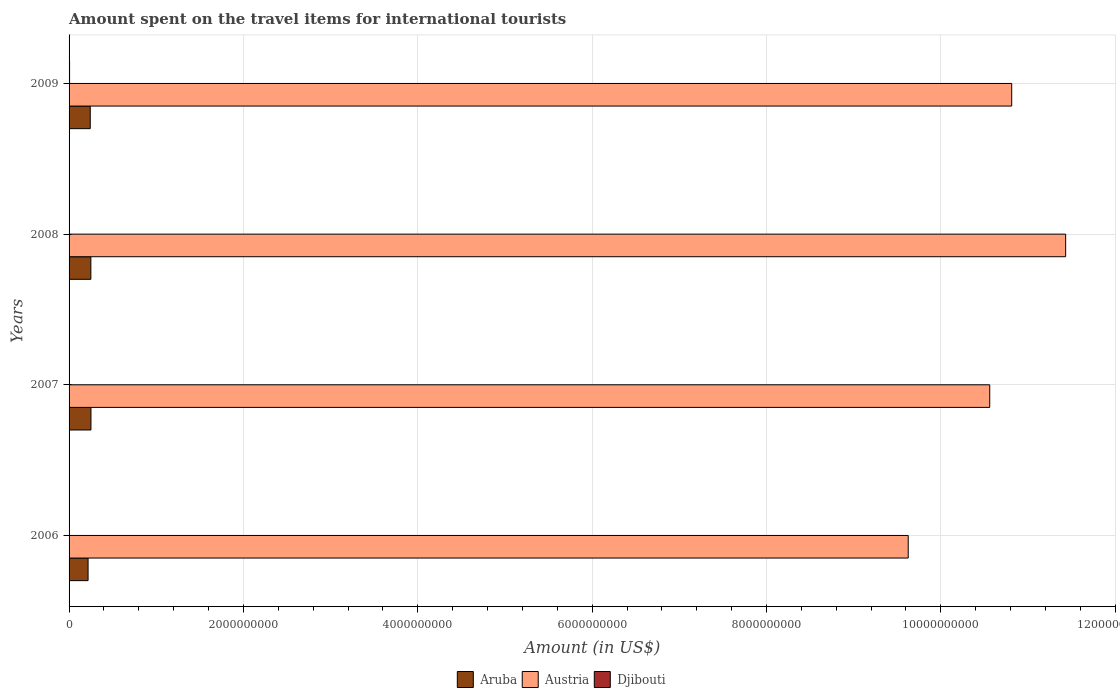How many different coloured bars are there?
Ensure brevity in your answer.  3. Are the number of bars on each tick of the Y-axis equal?
Offer a terse response. Yes. What is the label of the 3rd group of bars from the top?
Your response must be concise. 2007. In how many cases, is the number of bars for a given year not equal to the number of legend labels?
Provide a succinct answer. 0. What is the amount spent on the travel items for international tourists in Djibouti in 2008?
Provide a succinct answer. 3.70e+06. Across all years, what is the maximum amount spent on the travel items for international tourists in Aruba?
Your answer should be very brief. 2.51e+08. Across all years, what is the minimum amount spent on the travel items for international tourists in Djibouti?
Provide a succinct answer. 2.60e+06. What is the total amount spent on the travel items for international tourists in Aruba in the graph?
Your answer should be compact. 9.62e+08. What is the difference between the amount spent on the travel items for international tourists in Aruba in 2007 and that in 2008?
Ensure brevity in your answer.  1.00e+06. What is the difference between the amount spent on the travel items for international tourists in Djibouti in 2006 and the amount spent on the travel items for international tourists in Aruba in 2009?
Ensure brevity in your answer.  -2.40e+08. What is the average amount spent on the travel items for international tourists in Aruba per year?
Ensure brevity in your answer.  2.40e+08. In the year 2008, what is the difference between the amount spent on the travel items for international tourists in Djibouti and amount spent on the travel items for international tourists in Aruba?
Offer a very short reply. -2.46e+08. What is the ratio of the amount spent on the travel items for international tourists in Austria in 2006 to that in 2009?
Your answer should be compact. 0.89. Is the amount spent on the travel items for international tourists in Aruba in 2008 less than that in 2009?
Ensure brevity in your answer.  No. What is the difference between the highest and the second highest amount spent on the travel items for international tourists in Austria?
Ensure brevity in your answer.  6.19e+08. What is the difference between the highest and the lowest amount spent on the travel items for international tourists in Austria?
Make the answer very short. 1.81e+09. Is the sum of the amount spent on the travel items for international tourists in Austria in 2007 and 2008 greater than the maximum amount spent on the travel items for international tourists in Aruba across all years?
Offer a very short reply. Yes. What does the 1st bar from the top in 2009 represents?
Give a very brief answer. Djibouti. What does the 2nd bar from the bottom in 2009 represents?
Ensure brevity in your answer.  Austria. Is it the case that in every year, the sum of the amount spent on the travel items for international tourists in Austria and amount spent on the travel items for international tourists in Djibouti is greater than the amount spent on the travel items for international tourists in Aruba?
Your response must be concise. Yes. How many bars are there?
Provide a short and direct response. 12. Are all the bars in the graph horizontal?
Offer a terse response. Yes. How many years are there in the graph?
Your answer should be very brief. 4. How many legend labels are there?
Make the answer very short. 3. How are the legend labels stacked?
Offer a very short reply. Horizontal. What is the title of the graph?
Your answer should be very brief. Amount spent on the travel items for international tourists. Does "Uzbekistan" appear as one of the legend labels in the graph?
Offer a terse response. No. What is the label or title of the X-axis?
Give a very brief answer. Amount (in US$). What is the Amount (in US$) of Aruba in 2006?
Offer a very short reply. 2.18e+08. What is the Amount (in US$) in Austria in 2006?
Offer a very short reply. 9.63e+09. What is the Amount (in US$) of Djibouti in 2006?
Give a very brief answer. 3.50e+06. What is the Amount (in US$) of Aruba in 2007?
Ensure brevity in your answer.  2.51e+08. What is the Amount (in US$) in Austria in 2007?
Give a very brief answer. 1.06e+1. What is the Amount (in US$) of Djibouti in 2007?
Your response must be concise. 2.60e+06. What is the Amount (in US$) of Aruba in 2008?
Your answer should be compact. 2.50e+08. What is the Amount (in US$) of Austria in 2008?
Offer a terse response. 1.14e+1. What is the Amount (in US$) of Djibouti in 2008?
Offer a very short reply. 3.70e+06. What is the Amount (in US$) of Aruba in 2009?
Offer a very short reply. 2.43e+08. What is the Amount (in US$) of Austria in 2009?
Keep it short and to the point. 1.08e+1. What is the Amount (in US$) in Djibouti in 2009?
Ensure brevity in your answer.  5.80e+06. Across all years, what is the maximum Amount (in US$) of Aruba?
Give a very brief answer. 2.51e+08. Across all years, what is the maximum Amount (in US$) of Austria?
Your answer should be very brief. 1.14e+1. Across all years, what is the maximum Amount (in US$) of Djibouti?
Offer a terse response. 5.80e+06. Across all years, what is the minimum Amount (in US$) of Aruba?
Your answer should be very brief. 2.18e+08. Across all years, what is the minimum Amount (in US$) in Austria?
Make the answer very short. 9.63e+09. Across all years, what is the minimum Amount (in US$) in Djibouti?
Your response must be concise. 2.60e+06. What is the total Amount (in US$) of Aruba in the graph?
Ensure brevity in your answer.  9.62e+08. What is the total Amount (in US$) of Austria in the graph?
Provide a short and direct response. 4.24e+1. What is the total Amount (in US$) in Djibouti in the graph?
Your response must be concise. 1.56e+07. What is the difference between the Amount (in US$) in Aruba in 2006 and that in 2007?
Offer a very short reply. -3.30e+07. What is the difference between the Amount (in US$) in Austria in 2006 and that in 2007?
Provide a succinct answer. -9.35e+08. What is the difference between the Amount (in US$) of Aruba in 2006 and that in 2008?
Provide a succinct answer. -3.20e+07. What is the difference between the Amount (in US$) of Austria in 2006 and that in 2008?
Offer a very short reply. -1.81e+09. What is the difference between the Amount (in US$) of Djibouti in 2006 and that in 2008?
Offer a very short reply. -2.00e+05. What is the difference between the Amount (in US$) in Aruba in 2006 and that in 2009?
Offer a very short reply. -2.50e+07. What is the difference between the Amount (in US$) of Austria in 2006 and that in 2009?
Give a very brief answer. -1.19e+09. What is the difference between the Amount (in US$) in Djibouti in 2006 and that in 2009?
Your answer should be compact. -2.30e+06. What is the difference between the Amount (in US$) of Austria in 2007 and that in 2008?
Provide a succinct answer. -8.71e+08. What is the difference between the Amount (in US$) of Djibouti in 2007 and that in 2008?
Keep it short and to the point. -1.10e+06. What is the difference between the Amount (in US$) of Austria in 2007 and that in 2009?
Give a very brief answer. -2.52e+08. What is the difference between the Amount (in US$) of Djibouti in 2007 and that in 2009?
Give a very brief answer. -3.20e+06. What is the difference between the Amount (in US$) in Aruba in 2008 and that in 2009?
Ensure brevity in your answer.  7.00e+06. What is the difference between the Amount (in US$) of Austria in 2008 and that in 2009?
Your answer should be very brief. 6.19e+08. What is the difference between the Amount (in US$) in Djibouti in 2008 and that in 2009?
Give a very brief answer. -2.10e+06. What is the difference between the Amount (in US$) in Aruba in 2006 and the Amount (in US$) in Austria in 2007?
Provide a short and direct response. -1.03e+1. What is the difference between the Amount (in US$) in Aruba in 2006 and the Amount (in US$) in Djibouti in 2007?
Ensure brevity in your answer.  2.15e+08. What is the difference between the Amount (in US$) of Austria in 2006 and the Amount (in US$) of Djibouti in 2007?
Offer a terse response. 9.62e+09. What is the difference between the Amount (in US$) of Aruba in 2006 and the Amount (in US$) of Austria in 2008?
Offer a very short reply. -1.12e+1. What is the difference between the Amount (in US$) in Aruba in 2006 and the Amount (in US$) in Djibouti in 2008?
Provide a succinct answer. 2.14e+08. What is the difference between the Amount (in US$) in Austria in 2006 and the Amount (in US$) in Djibouti in 2008?
Your answer should be very brief. 9.62e+09. What is the difference between the Amount (in US$) in Aruba in 2006 and the Amount (in US$) in Austria in 2009?
Provide a short and direct response. -1.06e+1. What is the difference between the Amount (in US$) of Aruba in 2006 and the Amount (in US$) of Djibouti in 2009?
Offer a very short reply. 2.12e+08. What is the difference between the Amount (in US$) of Austria in 2006 and the Amount (in US$) of Djibouti in 2009?
Keep it short and to the point. 9.62e+09. What is the difference between the Amount (in US$) of Aruba in 2007 and the Amount (in US$) of Austria in 2008?
Offer a very short reply. -1.12e+1. What is the difference between the Amount (in US$) of Aruba in 2007 and the Amount (in US$) of Djibouti in 2008?
Your response must be concise. 2.47e+08. What is the difference between the Amount (in US$) in Austria in 2007 and the Amount (in US$) in Djibouti in 2008?
Offer a very short reply. 1.06e+1. What is the difference between the Amount (in US$) of Aruba in 2007 and the Amount (in US$) of Austria in 2009?
Make the answer very short. -1.06e+1. What is the difference between the Amount (in US$) of Aruba in 2007 and the Amount (in US$) of Djibouti in 2009?
Provide a short and direct response. 2.45e+08. What is the difference between the Amount (in US$) of Austria in 2007 and the Amount (in US$) of Djibouti in 2009?
Give a very brief answer. 1.06e+1. What is the difference between the Amount (in US$) of Aruba in 2008 and the Amount (in US$) of Austria in 2009?
Your response must be concise. -1.06e+1. What is the difference between the Amount (in US$) in Aruba in 2008 and the Amount (in US$) in Djibouti in 2009?
Offer a very short reply. 2.44e+08. What is the difference between the Amount (in US$) of Austria in 2008 and the Amount (in US$) of Djibouti in 2009?
Provide a short and direct response. 1.14e+1. What is the average Amount (in US$) in Aruba per year?
Offer a terse response. 2.40e+08. What is the average Amount (in US$) in Austria per year?
Your response must be concise. 1.06e+1. What is the average Amount (in US$) in Djibouti per year?
Provide a short and direct response. 3.90e+06. In the year 2006, what is the difference between the Amount (in US$) in Aruba and Amount (in US$) in Austria?
Your answer should be compact. -9.41e+09. In the year 2006, what is the difference between the Amount (in US$) of Aruba and Amount (in US$) of Djibouti?
Provide a succinct answer. 2.14e+08. In the year 2006, what is the difference between the Amount (in US$) in Austria and Amount (in US$) in Djibouti?
Offer a very short reply. 9.62e+09. In the year 2007, what is the difference between the Amount (in US$) of Aruba and Amount (in US$) of Austria?
Offer a terse response. -1.03e+1. In the year 2007, what is the difference between the Amount (in US$) of Aruba and Amount (in US$) of Djibouti?
Your answer should be very brief. 2.48e+08. In the year 2007, what is the difference between the Amount (in US$) in Austria and Amount (in US$) in Djibouti?
Your response must be concise. 1.06e+1. In the year 2008, what is the difference between the Amount (in US$) in Aruba and Amount (in US$) in Austria?
Offer a terse response. -1.12e+1. In the year 2008, what is the difference between the Amount (in US$) in Aruba and Amount (in US$) in Djibouti?
Provide a succinct answer. 2.46e+08. In the year 2008, what is the difference between the Amount (in US$) in Austria and Amount (in US$) in Djibouti?
Make the answer very short. 1.14e+1. In the year 2009, what is the difference between the Amount (in US$) of Aruba and Amount (in US$) of Austria?
Ensure brevity in your answer.  -1.06e+1. In the year 2009, what is the difference between the Amount (in US$) of Aruba and Amount (in US$) of Djibouti?
Your answer should be very brief. 2.37e+08. In the year 2009, what is the difference between the Amount (in US$) of Austria and Amount (in US$) of Djibouti?
Your answer should be compact. 1.08e+1. What is the ratio of the Amount (in US$) of Aruba in 2006 to that in 2007?
Your answer should be compact. 0.87. What is the ratio of the Amount (in US$) of Austria in 2006 to that in 2007?
Offer a terse response. 0.91. What is the ratio of the Amount (in US$) of Djibouti in 2006 to that in 2007?
Keep it short and to the point. 1.35. What is the ratio of the Amount (in US$) in Aruba in 2006 to that in 2008?
Ensure brevity in your answer.  0.87. What is the ratio of the Amount (in US$) of Austria in 2006 to that in 2008?
Keep it short and to the point. 0.84. What is the ratio of the Amount (in US$) of Djibouti in 2006 to that in 2008?
Provide a succinct answer. 0.95. What is the ratio of the Amount (in US$) of Aruba in 2006 to that in 2009?
Provide a short and direct response. 0.9. What is the ratio of the Amount (in US$) in Austria in 2006 to that in 2009?
Give a very brief answer. 0.89. What is the ratio of the Amount (in US$) of Djibouti in 2006 to that in 2009?
Give a very brief answer. 0.6. What is the ratio of the Amount (in US$) in Aruba in 2007 to that in 2008?
Your answer should be very brief. 1. What is the ratio of the Amount (in US$) of Austria in 2007 to that in 2008?
Offer a terse response. 0.92. What is the ratio of the Amount (in US$) in Djibouti in 2007 to that in 2008?
Your response must be concise. 0.7. What is the ratio of the Amount (in US$) of Aruba in 2007 to that in 2009?
Ensure brevity in your answer.  1.03. What is the ratio of the Amount (in US$) of Austria in 2007 to that in 2009?
Provide a short and direct response. 0.98. What is the ratio of the Amount (in US$) of Djibouti in 2007 to that in 2009?
Your answer should be very brief. 0.45. What is the ratio of the Amount (in US$) in Aruba in 2008 to that in 2009?
Offer a very short reply. 1.03. What is the ratio of the Amount (in US$) of Austria in 2008 to that in 2009?
Offer a terse response. 1.06. What is the ratio of the Amount (in US$) of Djibouti in 2008 to that in 2009?
Ensure brevity in your answer.  0.64. What is the difference between the highest and the second highest Amount (in US$) in Austria?
Give a very brief answer. 6.19e+08. What is the difference between the highest and the second highest Amount (in US$) of Djibouti?
Give a very brief answer. 2.10e+06. What is the difference between the highest and the lowest Amount (in US$) of Aruba?
Provide a succinct answer. 3.30e+07. What is the difference between the highest and the lowest Amount (in US$) in Austria?
Keep it short and to the point. 1.81e+09. What is the difference between the highest and the lowest Amount (in US$) of Djibouti?
Provide a short and direct response. 3.20e+06. 